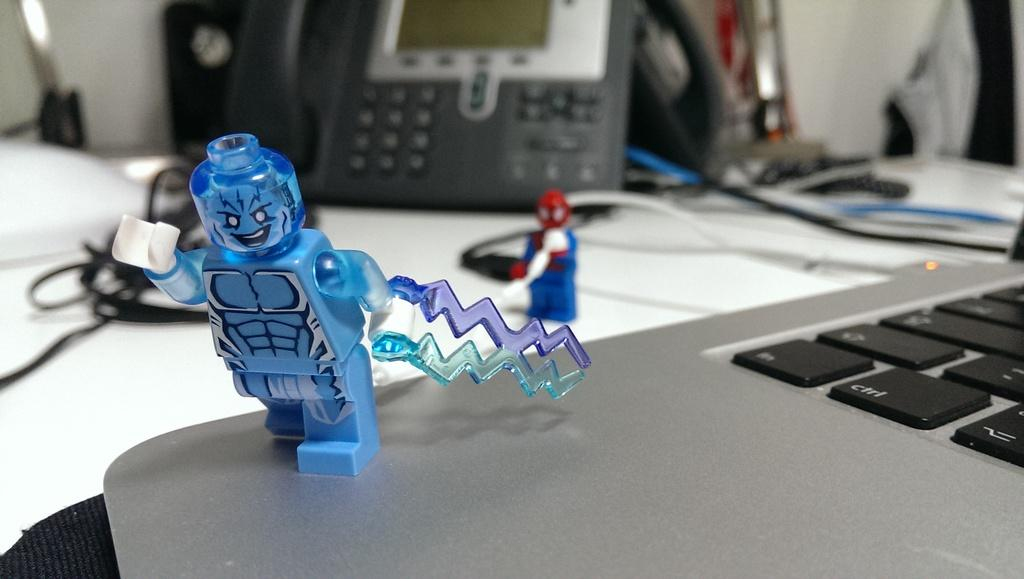What piece of furniture is present in the image? There is a table in the image. What electronic device is on the table? There is a laptop on the table. What type of objects are also on the table? There are toys on the table. What communication device is on the table? There is a telephone on the table. Where is the nearest airport in the image? There is no airport present in the image; it only shows a table with a laptop, toys, and a telephone. 